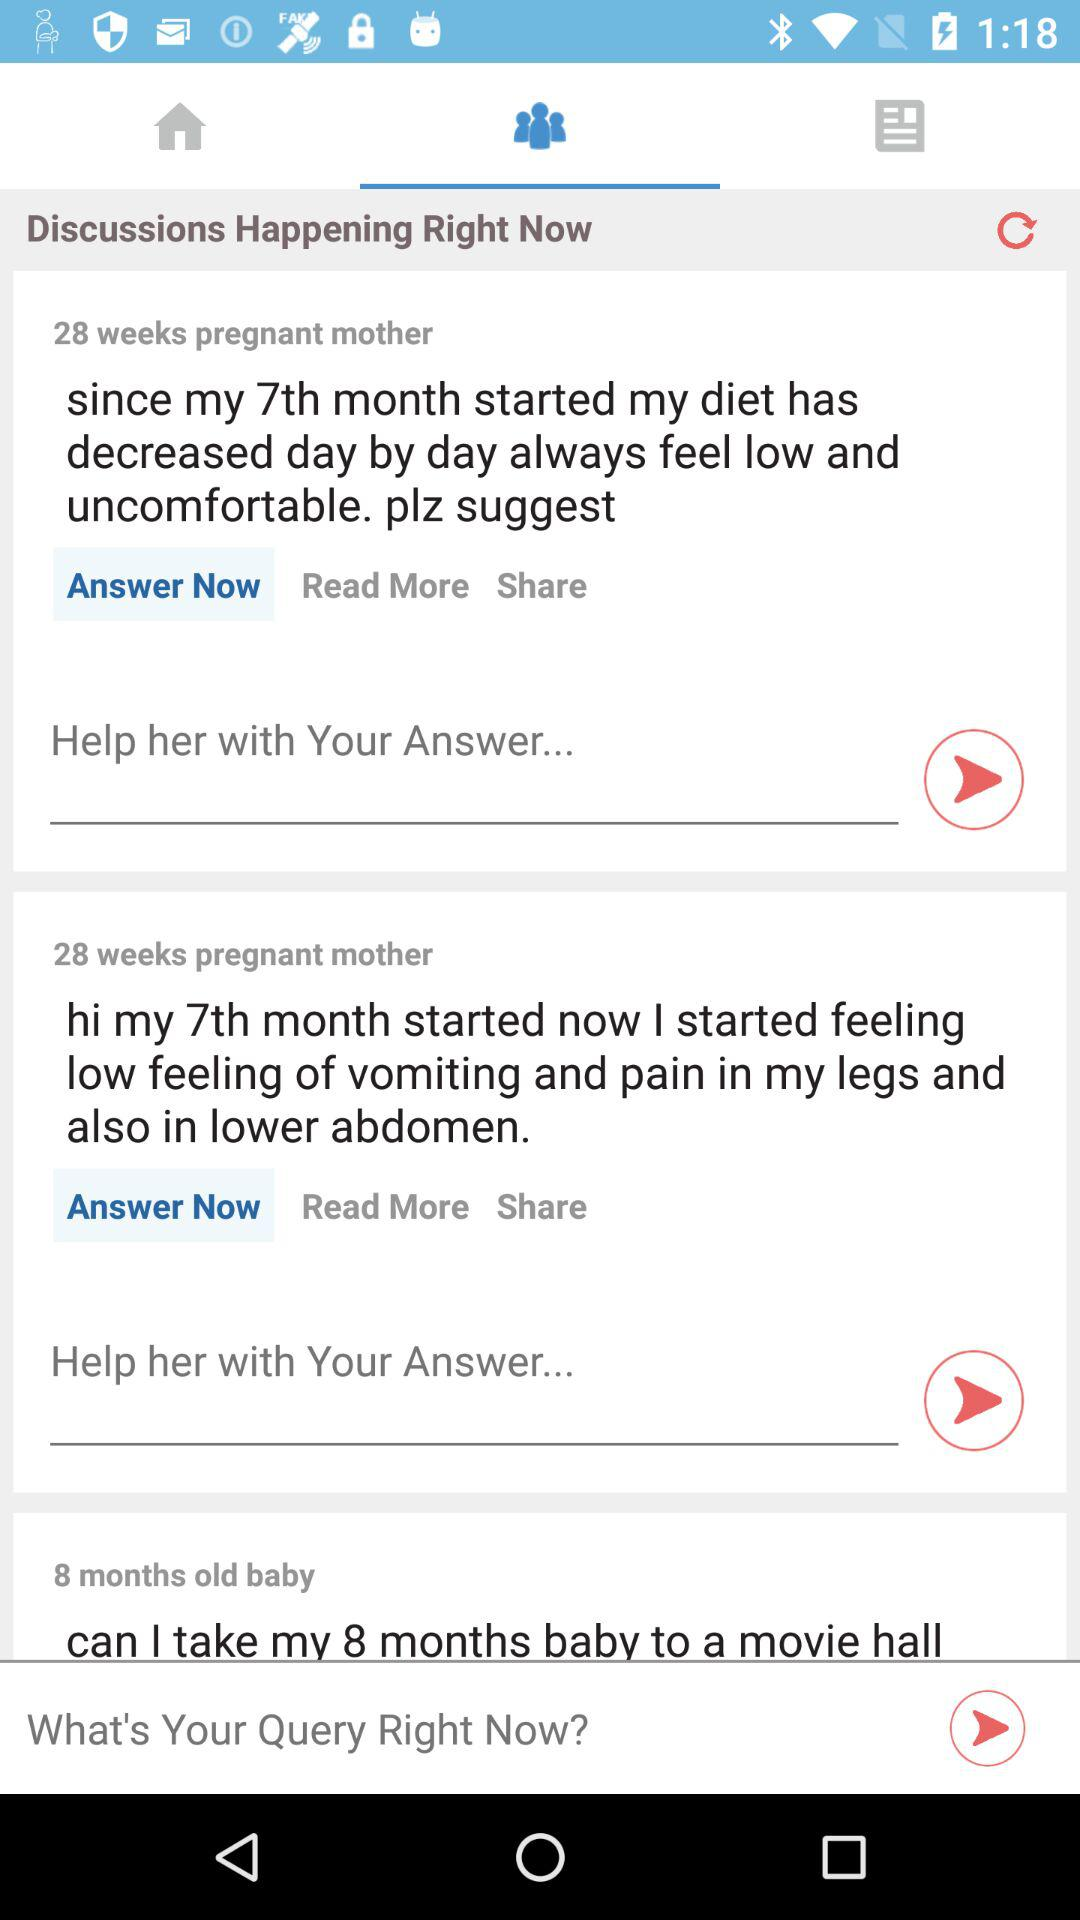What is the age of the baby? The age of the baby is 8 months. 